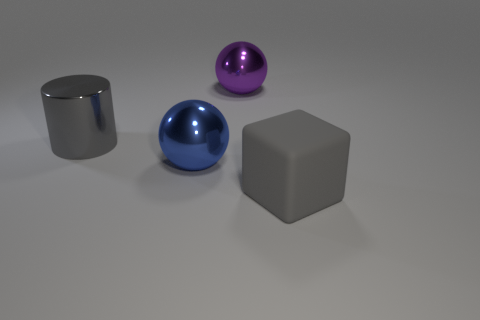Can you describe the lighting and shadows observed in the image? The image shows a single, strong light source from above and to the left, as evidenced by the bright highlights on the top left of the objects and the shadows that extend towards the bottom right. The shadows are soft-edged, indicating that the light source may be large or diffused, and their angles help give a sense of the three-dimensional form of the objects and their position in space. 